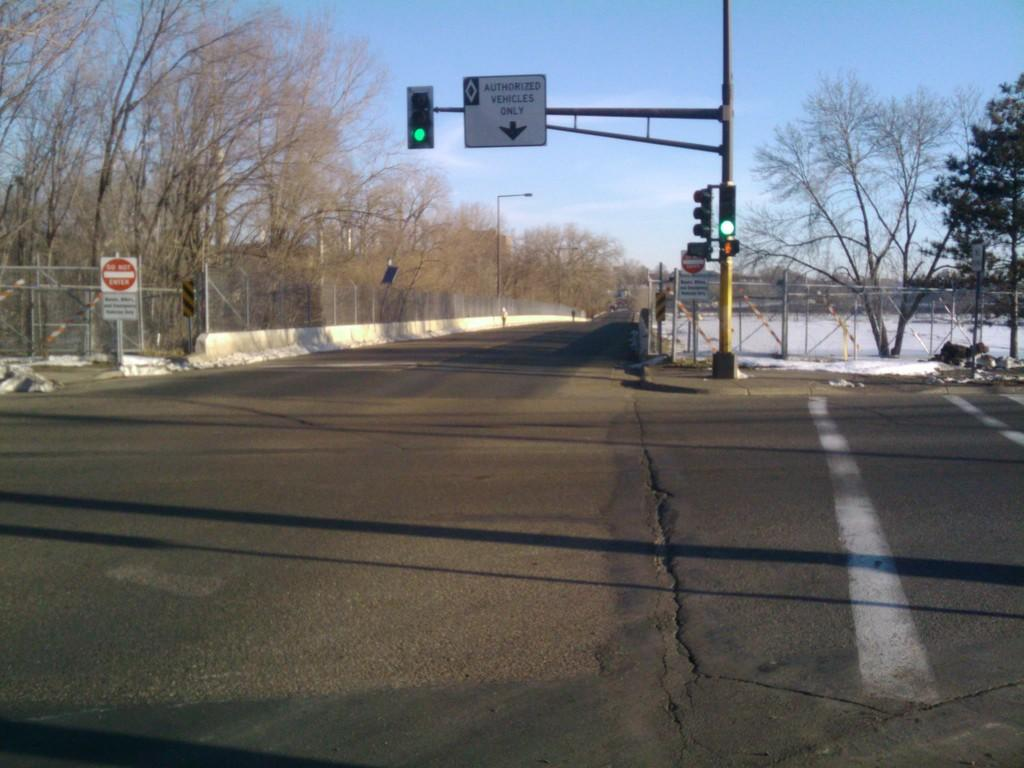What is the main feature of the image? There is a road in the image. What can be seen on the right side of the road? There is a traffic signal pole on the right side of the road. What is present on the left side of the road? There are many dry trees on the left side of the road. What is visible in the background of the image? There is a sky visible in the background of the image. What type of scarf is being used to control the traffic on the road? There is no scarf present in the image, and traffic control is not being performed by a scarf. How many rail tracks are visible in the image? There are no rail tracks visible in the image; it features a road and dry trees. 